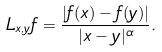<formula> <loc_0><loc_0><loc_500><loc_500>L _ { x , y } f = \frac { | f ( x ) - f ( y ) | } { | x - y | ^ { \alpha } } .</formula> 